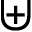<formula> <loc_0><loc_0><loc_500><loc_500>\uplus</formula> 